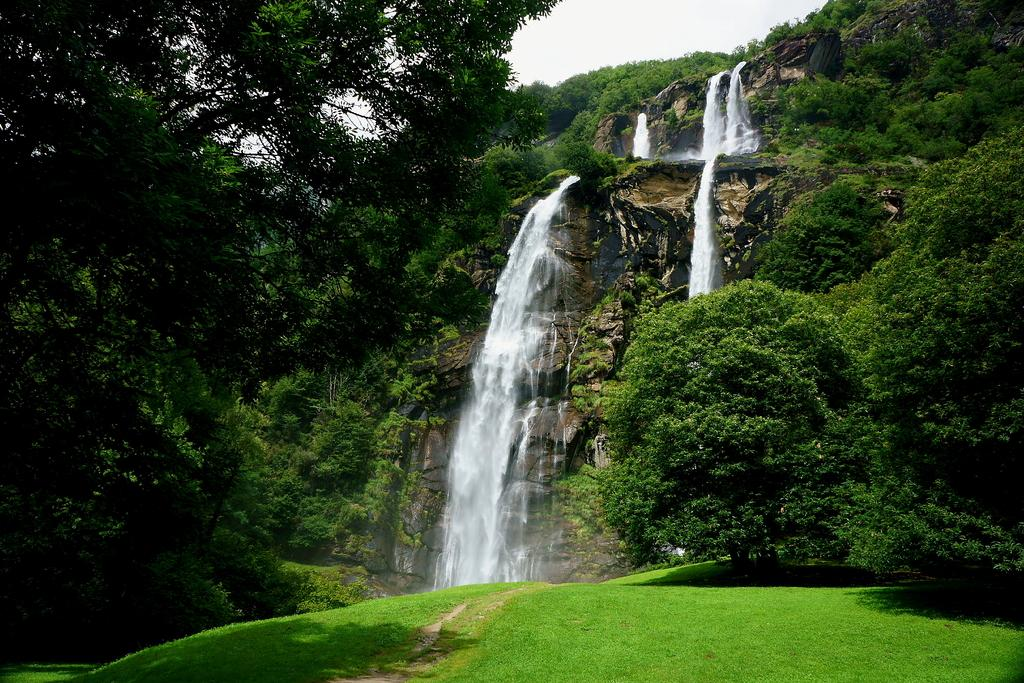What type of vegetation can be seen in the image? There is grass and trees visible in the image. What is the ground like in the image? The ground is visible in the image. What can be seen in the background of the image? There is a mountain, trees, water falling from the mountain, and the sky visible in the background of the image. Where is the bell located in the image? There is no bell present in the image. What type of vehicle can be seen driving through the water in the image? There is no vehicle present in the image, let alone one driving through water. 